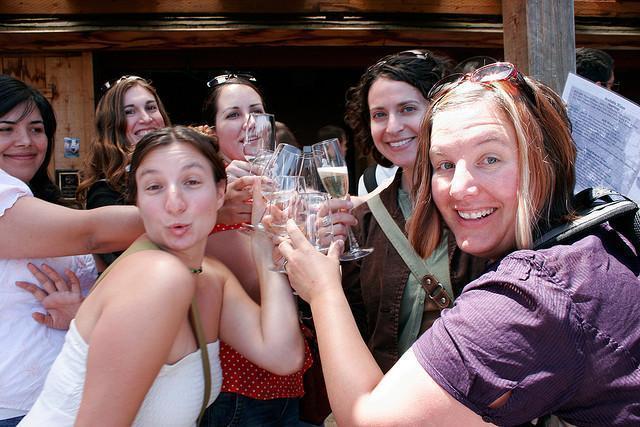What are the woman raising?
From the following set of four choices, select the accurate answer to respond to the question.
Options: Cows, glasses, chickens, graduation hats. Glasses. 